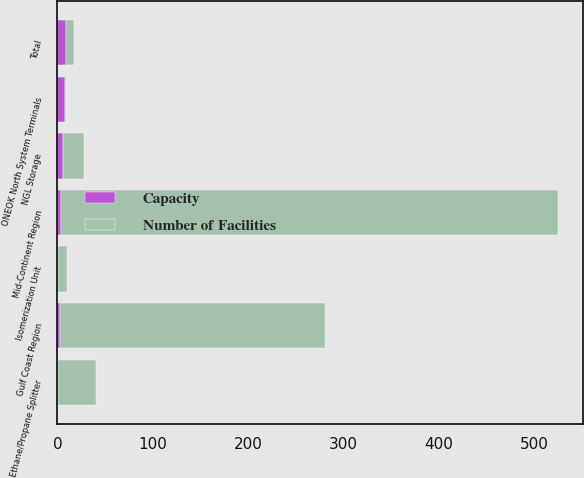<chart> <loc_0><loc_0><loc_500><loc_500><stacked_bar_chart><ecel><fcel>Gulf Coast Region<fcel>Mid-Continent Region<fcel>Isomerization Unit<fcel>Ethane/Propane Splitter<fcel>Total<fcel>NGL Storage<fcel>ONEOK North System Terminals<nl><fcel>Capacity<fcel>3<fcel>4<fcel>1<fcel>1<fcel>9<fcel>6<fcel>8<nl><fcel>Number of Facilities<fcel>278<fcel>521<fcel>9<fcel>40<fcel>8<fcel>22.2<fcel>1<nl></chart> 